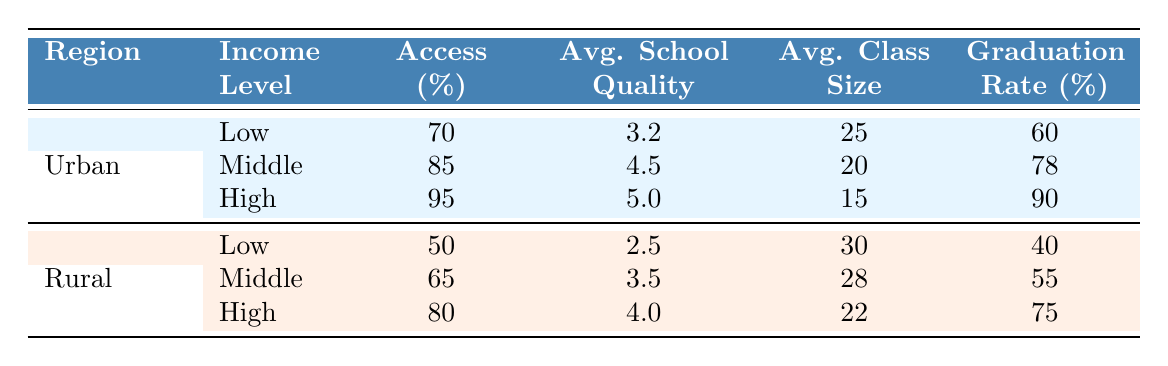What is the access percentage for low-income students in urban areas? The access percentage for low-income students in urban areas is specified in the table under the "Urban" row and "Low" income level, which shows a value of 70.
Answer: 70 What is the average school quality rating for middle-income students in rural areas? The average school quality rating for middle-income students in rural regions is located in the "Rural" row and "Middle" income level, which indicates a rating of 3.5.
Answer: 3.5 Is the graduation rate for high-income students in urban areas higher than that of low-income students in rural areas? The graduation rate for high-income students in urban areas is 90, while the graduation rate for low-income students in rural areas is 40. Since 90 is greater than 40, the statement is true.
Answer: Yes What is the average class size for middle-income students across both urban and rural areas? First, we find the average class size for middle-income students in both regions: Urban has an average class size of 20, and Rural has 28. Adding them gives 20 + 28 = 48. Then, we divide by 2 to get the average: 48/2 = 24.
Answer: 24 How much lower is the access percentage for low-income students in rural areas compared to urban areas? The access percentage for low-income students in urban areas is 70, while for their rural counterparts it is 50. To find the difference, we subtract 50 from 70: 70 - 50 = 20. Thus, the access percentage in rural areas is 20% lower than in urban areas.
Answer: 20 Is there a significant difference in average school quality ratings between high-income students in urban areas and low-income students in rural areas? The average school quality rating for high-income students in urban areas is 5.0, while for low-income students in rural areas, it is 2.5. The difference here is 5.0 - 2.5 = 2.5, indicating a significant difference in ratings as it is quite large.
Answer: Yes What is the average graduation rate for all income levels in rural areas? The graduation rates for rural areas are 40 for low-income, 55 for middle-income, and 75 for high-income. Adding these gives 40 + 55 + 75 = 170. Then, dividing by 3 gives an average of 170/3 ≈ 56.67.
Answer: 56.67 Which income level in rural areas has the highest graduation rate? By checking the graduation rates in the rural area section, low-income has 40, middle-income has 55, and high-income has 75. The highest graduation rate corresponds to the high-income group.
Answer: High 